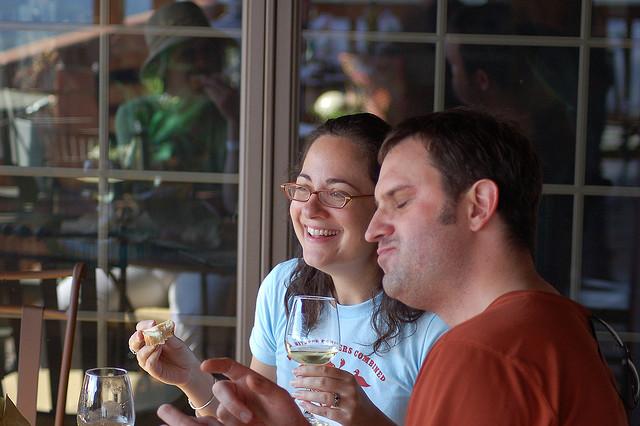What color is the guys shirt?
Answer briefly. Orange. Are these two people talking to each other?
Quick response, please. Yes. What does the woman's shirt say?
Answer briefly. Combined. What color is the drink in the glass?
Concise answer only. Yellow. How many females are in the photo?
Give a very brief answer. 1. Is the man waiting?
Write a very short answer. No. How many reading glasses do you see?
Be succinct. 1. How  many people are wearing glasses?
Give a very brief answer. 1. Is everyone in the photo an adult?
Short answer required. Yes. Is the person drinking a beverage?
Be succinct. Yes. No it is blurry?
Answer briefly. No. Does the couple appear to be eating outdoors?
Short answer required. Yes. Is the photo clear?
Be succinct. Yes. 